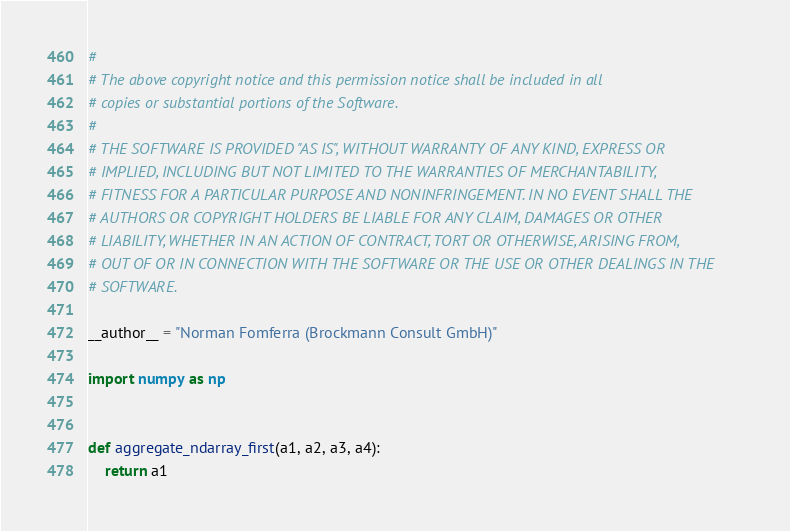<code> <loc_0><loc_0><loc_500><loc_500><_Python_>#
# The above copyright notice and this permission notice shall be included in all
# copies or substantial portions of the Software.
#
# THE SOFTWARE IS PROVIDED "AS IS", WITHOUT WARRANTY OF ANY KIND, EXPRESS OR
# IMPLIED, INCLUDING BUT NOT LIMITED TO THE WARRANTIES OF MERCHANTABILITY,
# FITNESS FOR A PARTICULAR PURPOSE AND NONINFRINGEMENT. IN NO EVENT SHALL THE
# AUTHORS OR COPYRIGHT HOLDERS BE LIABLE FOR ANY CLAIM, DAMAGES OR OTHER
# LIABILITY, WHETHER IN AN ACTION OF CONTRACT, TORT OR OTHERWISE, ARISING FROM,
# OUT OF OR IN CONNECTION WITH THE SOFTWARE OR THE USE OR OTHER DEALINGS IN THE
# SOFTWARE.

__author__ = "Norman Fomferra (Brockmann Consult GmbH)"

import numpy as np


def aggregate_ndarray_first(a1, a2, a3, a4):
    return a1

</code> 